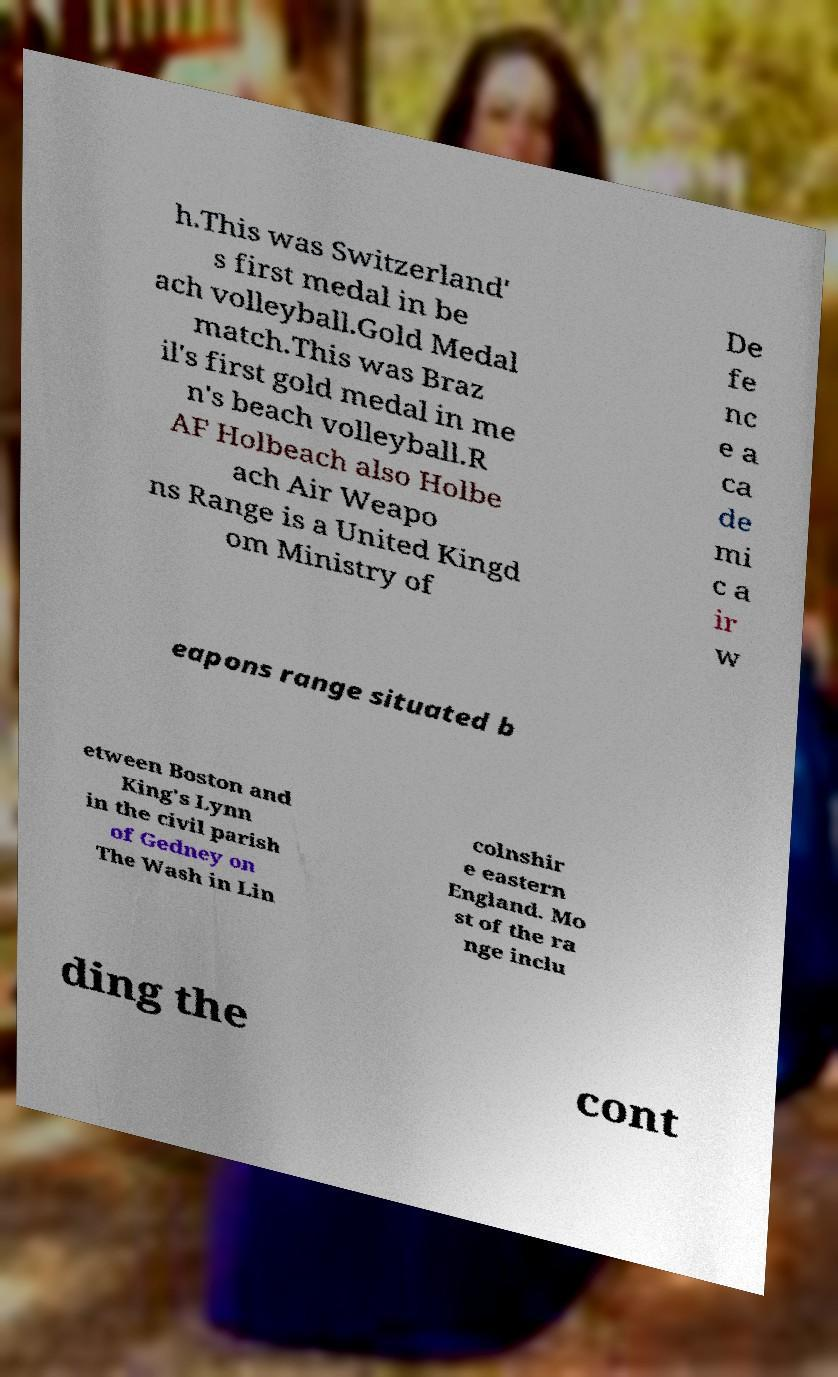What messages or text are displayed in this image? I need them in a readable, typed format. h.This was Switzerland' s first medal in be ach volleyball.Gold Medal match.This was Braz il's first gold medal in me n's beach volleyball.R AF Holbeach also Holbe ach Air Weapo ns Range is a United Kingd om Ministry of De fe nc e a ca de mi c a ir w eapons range situated b etween Boston and King's Lynn in the civil parish of Gedney on The Wash in Lin colnshir e eastern England. Mo st of the ra nge inclu ding the cont 